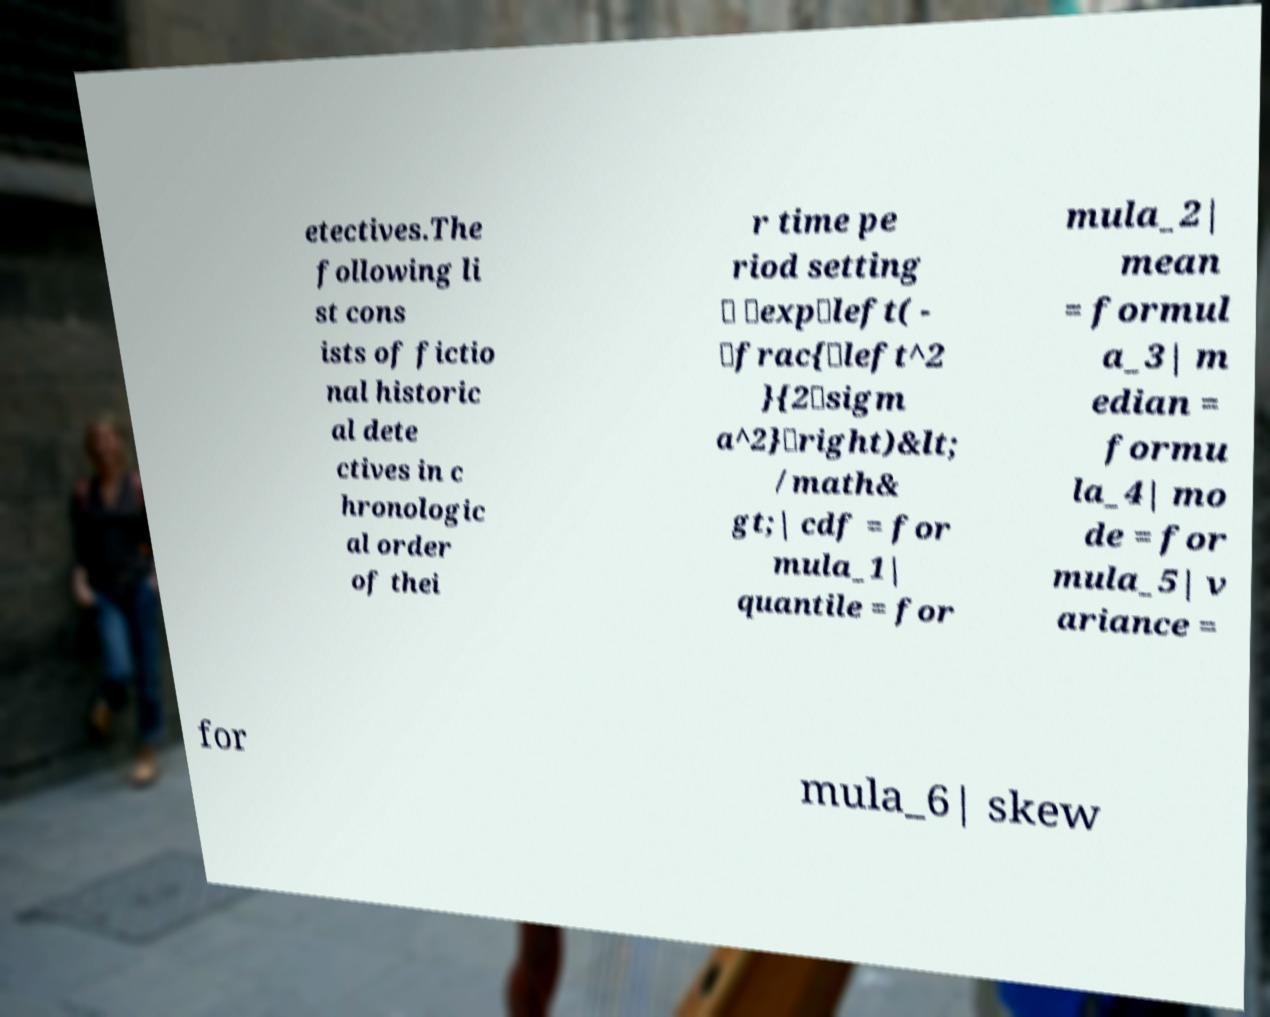For documentation purposes, I need the text within this image transcribed. Could you provide that? etectives.The following li st cons ists of fictio nal historic al dete ctives in c hronologic al order of thei r time pe riod setting \ \exp\left( - \frac{\left^2 }{2\sigm a^2}\right)&lt; /math& gt;| cdf = for mula_1| quantile = for mula_2| mean = formul a_3| m edian = formu la_4| mo de = for mula_5| v ariance = for mula_6| skew 